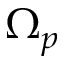Convert formula to latex. <formula><loc_0><loc_0><loc_500><loc_500>\Omega _ { p }</formula> 